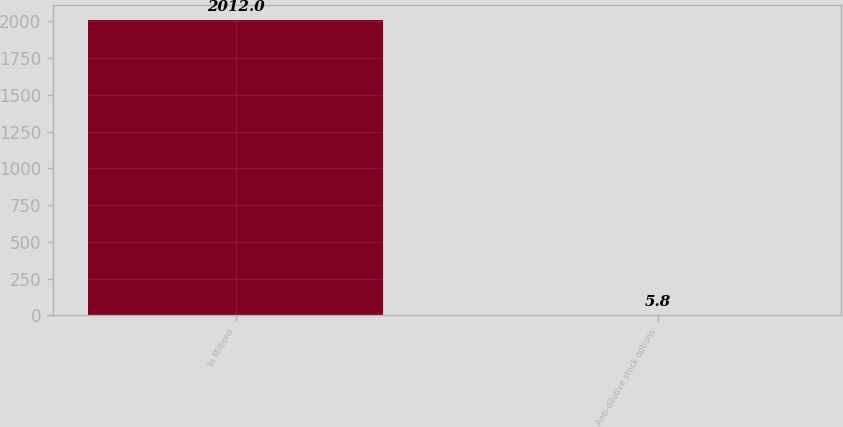<chart> <loc_0><loc_0><loc_500><loc_500><bar_chart><fcel>In Millions<fcel>Anti-dilutive stock options<nl><fcel>2012<fcel>5.8<nl></chart> 